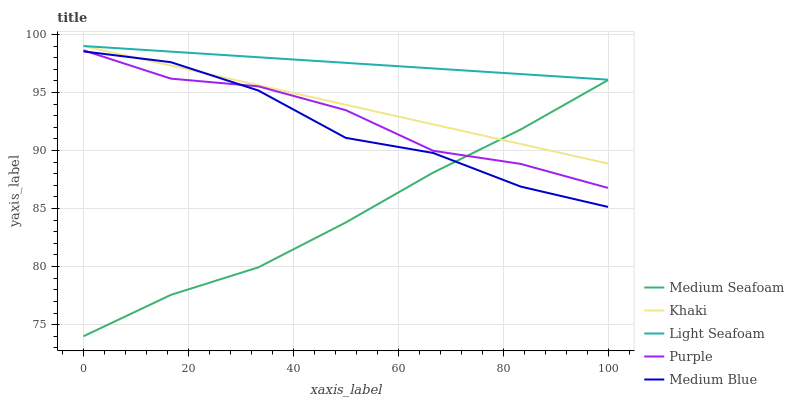Does Medium Seafoam have the minimum area under the curve?
Answer yes or no. Yes. Does Light Seafoam have the maximum area under the curve?
Answer yes or no. Yes. Does Khaki have the minimum area under the curve?
Answer yes or no. No. Does Khaki have the maximum area under the curve?
Answer yes or no. No. Is Light Seafoam the smoothest?
Answer yes or no. Yes. Is Medium Blue the roughest?
Answer yes or no. Yes. Is Khaki the smoothest?
Answer yes or no. No. Is Khaki the roughest?
Answer yes or no. No. Does Khaki have the lowest value?
Answer yes or no. No. Does Light Seafoam have the highest value?
Answer yes or no. Yes. Does Medium Blue have the highest value?
Answer yes or no. No. Is Medium Blue less than Light Seafoam?
Answer yes or no. Yes. Is Light Seafoam greater than Medium Seafoam?
Answer yes or no. Yes. Does Khaki intersect Medium Seafoam?
Answer yes or no. Yes. Is Khaki less than Medium Seafoam?
Answer yes or no. No. Is Khaki greater than Medium Seafoam?
Answer yes or no. No. Does Medium Blue intersect Light Seafoam?
Answer yes or no. No. 